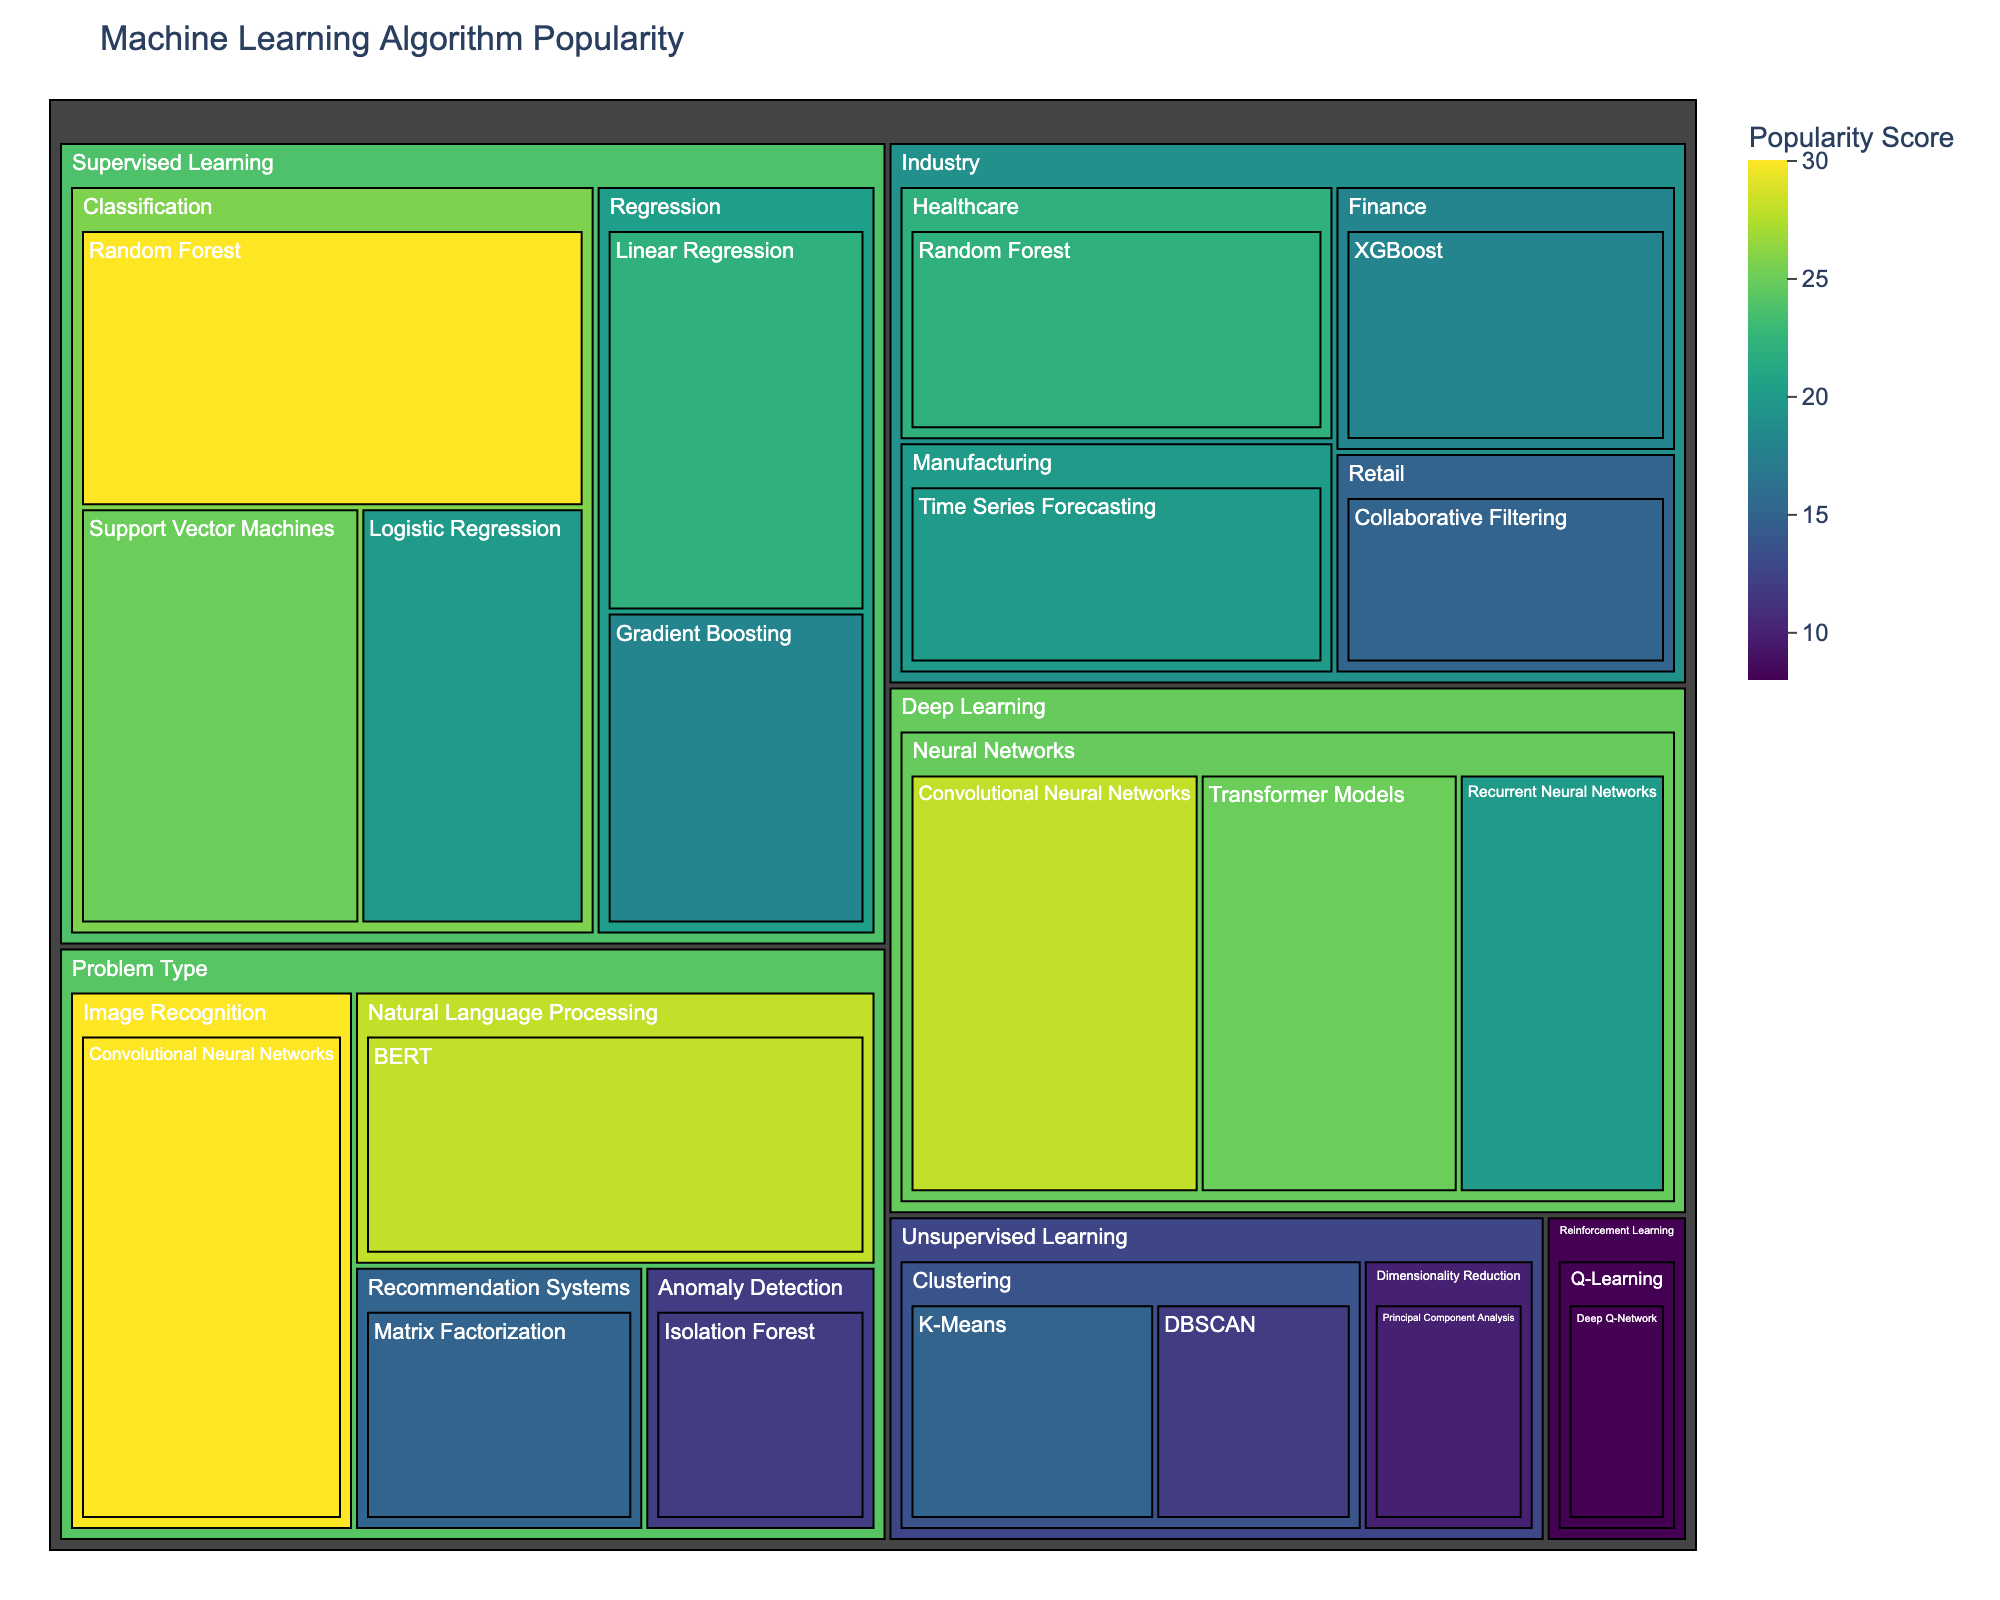What is the title of the treemap? The title is displayed at the top of the figure. It describes the overall content of the treemap and provides context for the viewer.
Answer: Machine Learning Algorithm Popularity Which supervised learning classification algorithm has the highest popularity score? The treemap uses color intensity and section size to represent the popularity score. The highest score under supervised learning -> classification is the largest and darkest.
Answer: Random Forest How many problem types are represented in the treemap? Each problem type will have its own section in the treemap. We count the distinct problem types visible.
Answer: 4 In the category "Industry", which algorithm is mapped to "Healthcare"? Locate the "Industry" category, then find its "Healthcare" subcategory to see the corresponding algorithm.
Answer: Random Forest What is the combined popularity score of all algorithms used in "Deep Learning"? Add up the popularity scores for Convolutional Neural Networks, Recurrent Neural Networks, and Transformer Models.
Answer: 73 Which category contains the algorithm with the least popularity? Identify the smallest section, which represents the least popular algorithm. Then, find out which high-level category it falls under.
Answer: Unsupervised Learning How does the popularity of "Support Vector Machines" compare to "Gradient Boosting"? Locate both algorithms and compare their values shown on the treemap.
Answer: Support Vector Machines > Gradient Boosting What is the difference in popularity scores between "XGBoost" under Finance and "Random Forest" under Healthcare in the Industry category? Subtract the value of Random Forest under Healthcare from XGBoost under Finance.
Answer: -4 Which algorithm is used for "Time Series Forecasting" in the Manufacturing Industry? Locate the Industry category and then find the subcategory Manufacturing to see the corresponding algorithm.
Answer: Time Series Forecasting Based on popularity, which problem type appears to be the most significant in the treemap? Observe the sizes and color intensities of problems. The one occupying the largest and darkest section is the most significant.
Answer: Image Recognition 